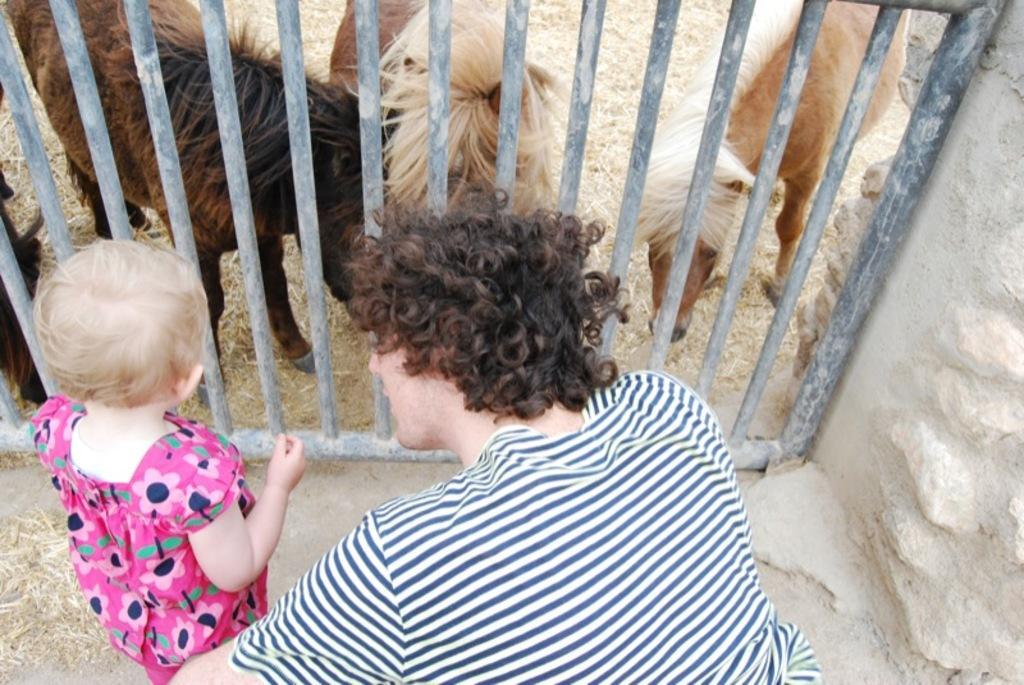In one or two sentences, can you explain what this image depicts? In this image there are two persons in the front. In the center there is a fence and behind the fence there are goats. 